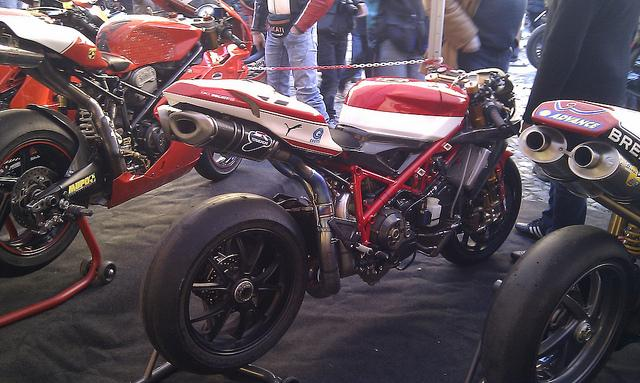What type of vehicle are these?

Choices:
A) truck
B) motorcycle
C) helicopter
D) bicycle motorcycle 